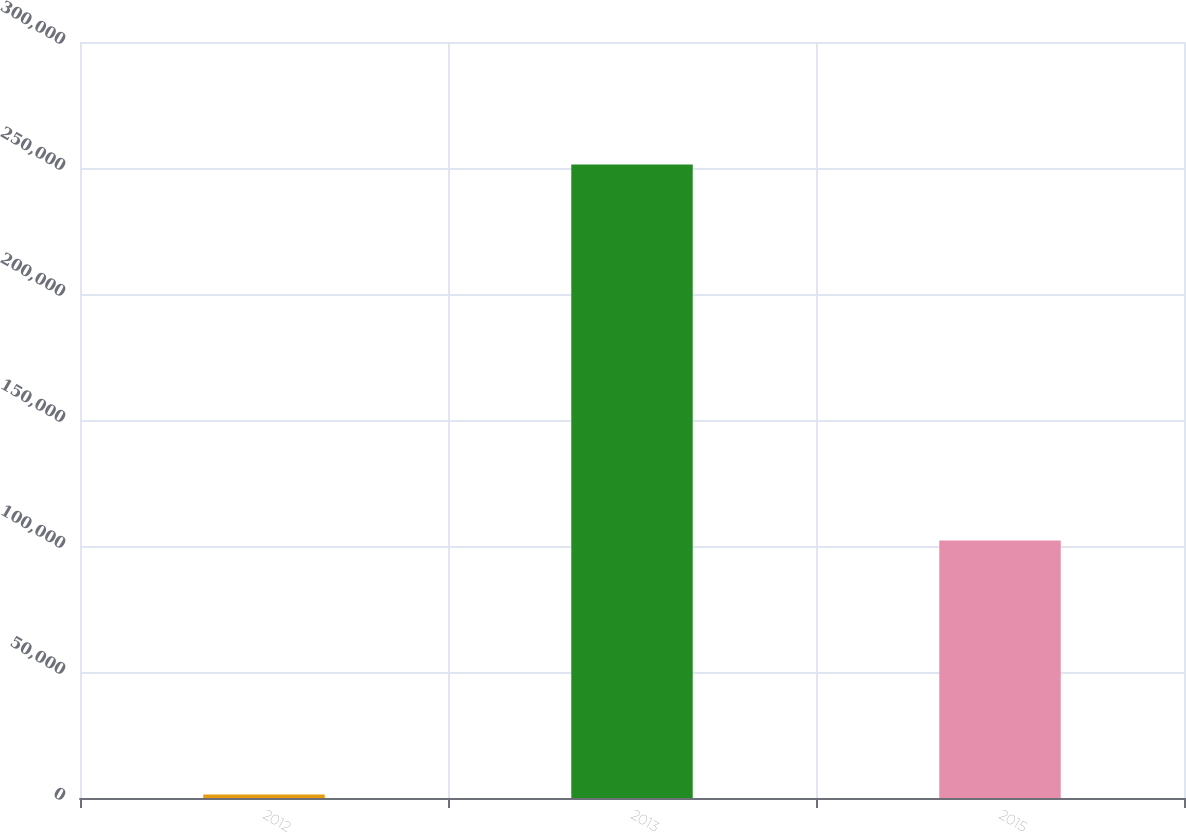<chart> <loc_0><loc_0><loc_500><loc_500><bar_chart><fcel>2012<fcel>2013<fcel>2015<nl><fcel>1409<fcel>251416<fcel>102175<nl></chart> 